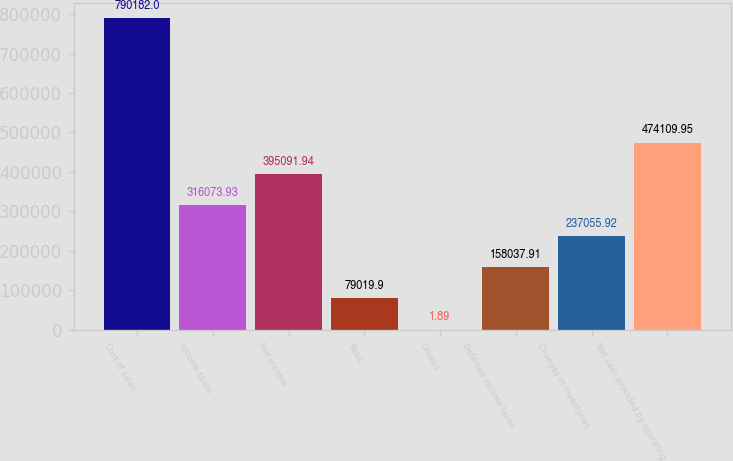<chart> <loc_0><loc_0><loc_500><loc_500><bar_chart><fcel>Cost of sales<fcel>Income taxes<fcel>Net income<fcel>Basic<fcel>Diluted<fcel>Deferred income taxes<fcel>Changes in inventories<fcel>Net cash provided by operating<nl><fcel>790182<fcel>316074<fcel>395092<fcel>79019.9<fcel>1.89<fcel>158038<fcel>237056<fcel>474110<nl></chart> 